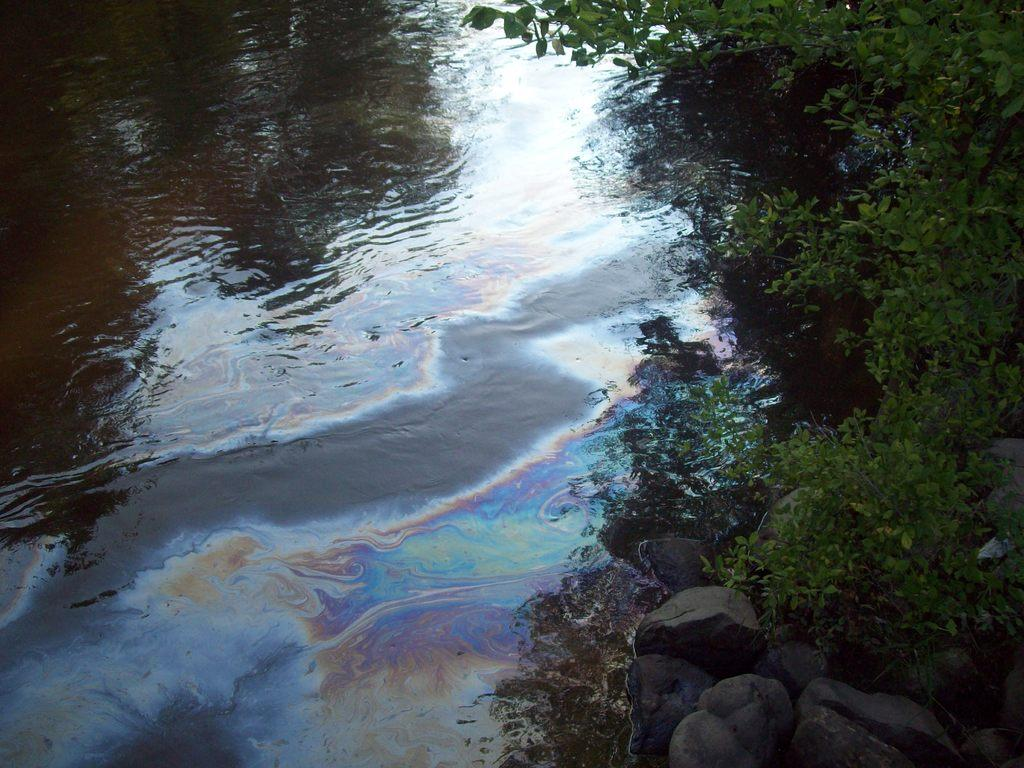What is the primary element visible in the image? There is water in the image. What can be seen on the right side of the image? There are trees and rocks on the right side of the image. What is visible on the surface of the water? There are reflections on the water. What substance is floating on the water? Oil is floating on the water. What type of vacation is being advertised in the image? There is no advertisement or indication of a vacation in the image; it primarily features water, trees, rocks, reflections, and oil. 